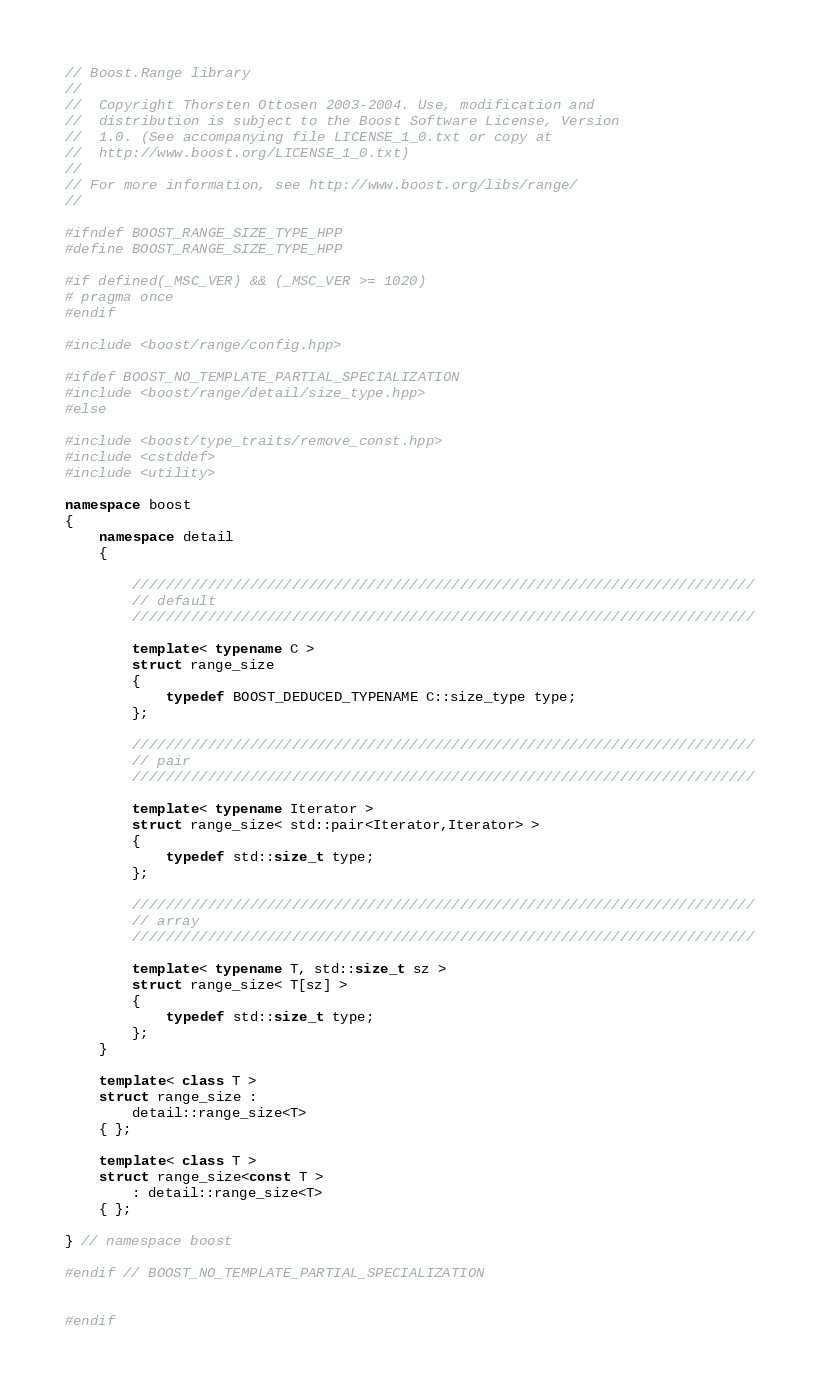<code> <loc_0><loc_0><loc_500><loc_500><_C++_>// Boost.Range library
//
//  Copyright Thorsten Ottosen 2003-2004. Use, modification and
//  distribution is subject to the Boost Software License, Version
//  1.0. (See accompanying file LICENSE_1_0.txt or copy at
//  http://www.boost.org/LICENSE_1_0.txt)
//
// For more information, see http://www.boost.org/libs/range/
//

#ifndef BOOST_RANGE_SIZE_TYPE_HPP
#define BOOST_RANGE_SIZE_TYPE_HPP

#if defined(_MSC_VER) && (_MSC_VER >= 1020)
# pragma once
#endif

#include <boost/range/config.hpp>

#ifdef BOOST_NO_TEMPLATE_PARTIAL_SPECIALIZATION
#include <boost/range/detail/size_type.hpp>
#else

#include <boost/type_traits/remove_const.hpp>
#include <cstddef>
#include <utility>

namespace boost
{
    namespace detail
    {

        //////////////////////////////////////////////////////////////////////////
        // default
        //////////////////////////////////////////////////////////////////////////
    
        template< typename C >
        struct range_size
        {
            typedef BOOST_DEDUCED_TYPENAME C::size_type type;
        };
    
        //////////////////////////////////////////////////////////////////////////
        // pair
        //////////////////////////////////////////////////////////////////////////
    
        template< typename Iterator >
        struct range_size< std::pair<Iterator,Iterator> >
        {
            typedef std::size_t type;
        };
    
        //////////////////////////////////////////////////////////////////////////
        // array
        //////////////////////////////////////////////////////////////////////////
    
        template< typename T, std::size_t sz >
        struct range_size< T[sz] >
        {
            typedef std::size_t type;
        };
    }

    template< class T >
    struct range_size : 
        detail::range_size<T>
    { };

    template< class T >
    struct range_size<const T >
        : detail::range_size<T>
    { };
    
} // namespace boost

#endif // BOOST_NO_TEMPLATE_PARTIAL_SPECIALIZATION


#endif
</code> 